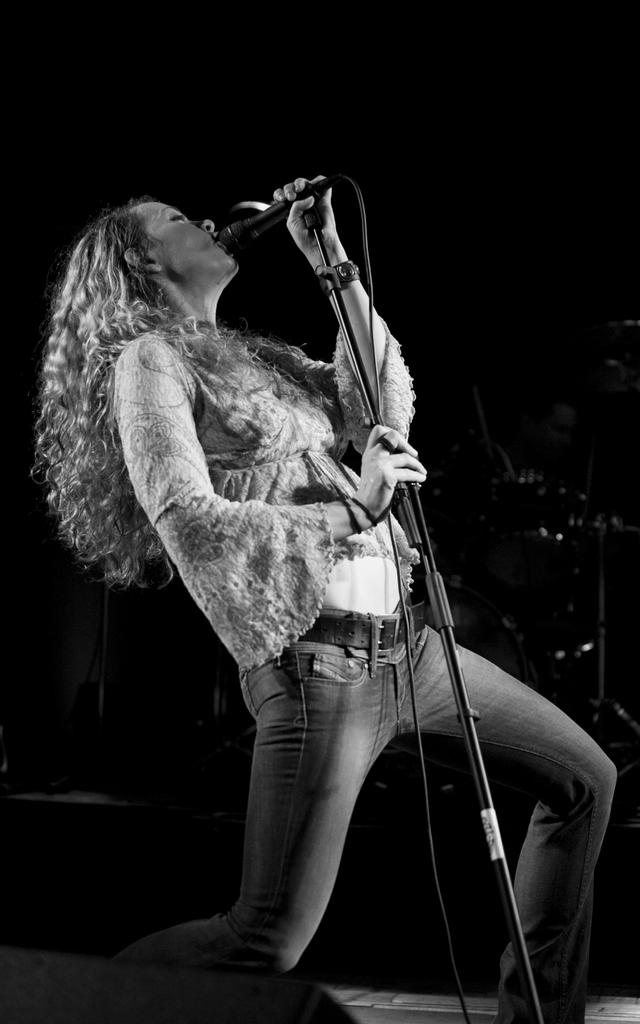Who is the main subject in the image? There is a woman in the image. What is the woman holding in her hand? The woman is holding a mic with her hand. What is the woman doing in the image? The woman is singing. What can be observed about the background of the image? The background of the image is dark. Can you see any corks in the image? There are no corks present in the image. Does the woman appear to be feeling any shame while singing in the image? The image does not provide any information about the woman's emotions, so it cannot be determined if she is feeling any shame. 